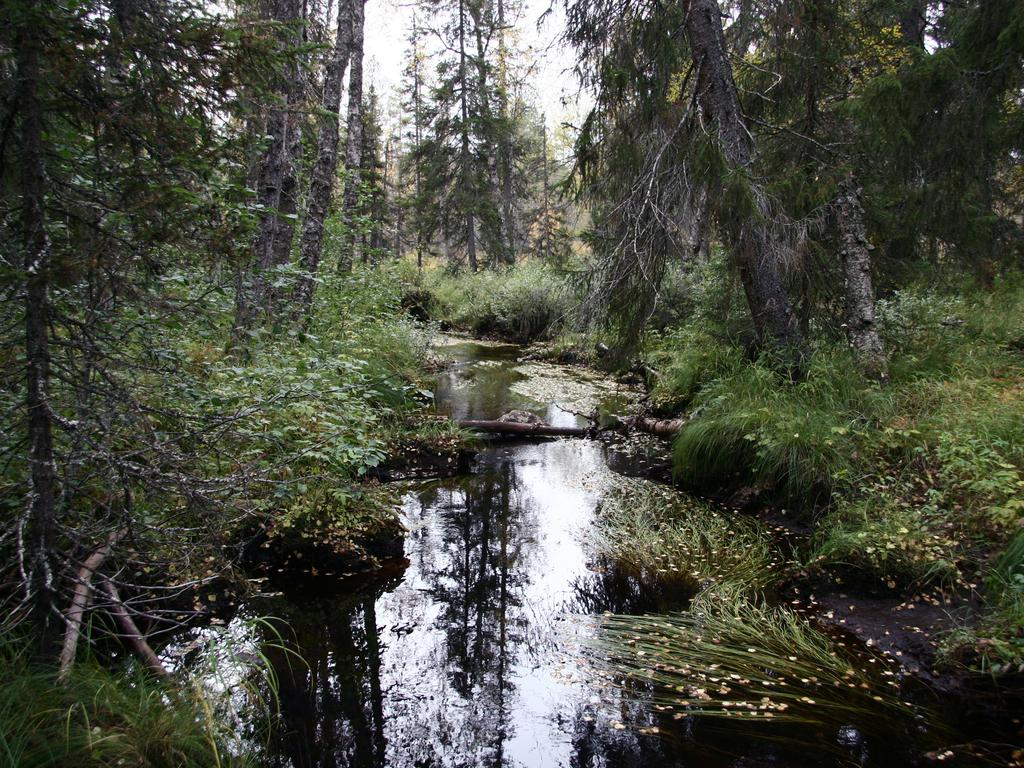What type of body of water is present in the image? There is a pond in the picture. What can be seen on the left side of the image? There are trees on the left side of the image. What is present on the right side of the image? There are trees and planets visible on the right side of the image. What type of harmony can be heard in the image? There is no audible sound or harmony present in the image, as it is a still picture. 